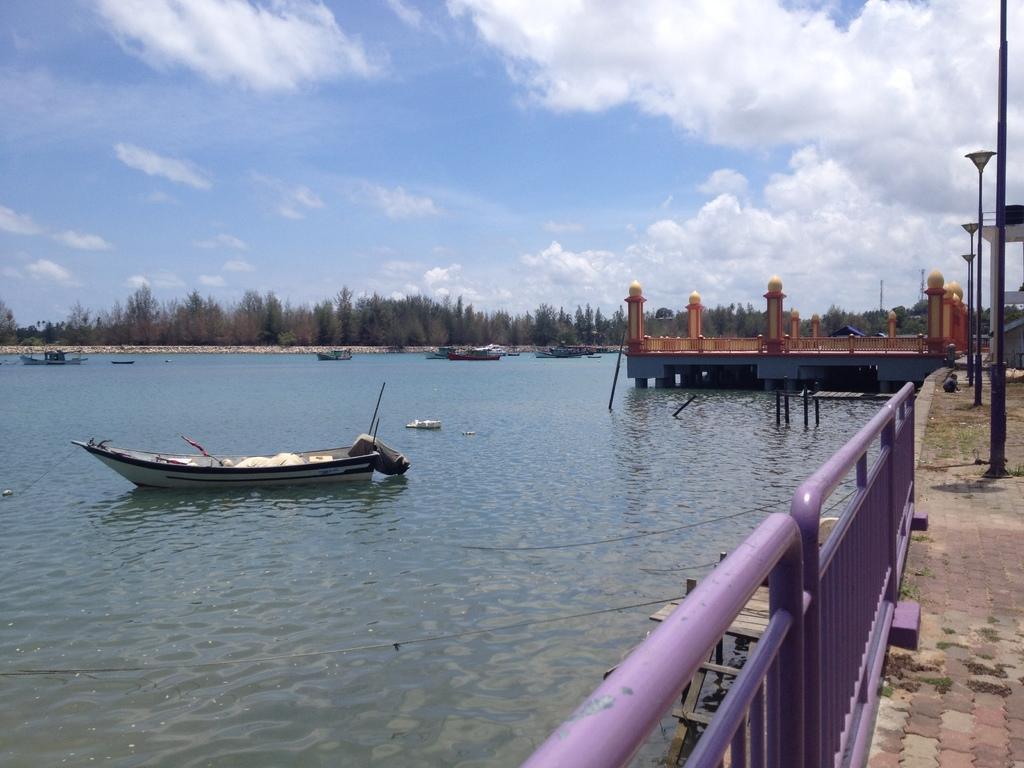Could you give a brief overview of what you see in this image? In this image, I can see a boat in front on the water and there is a path over here. In the background I can see lots of trees, street lights and the sky. 